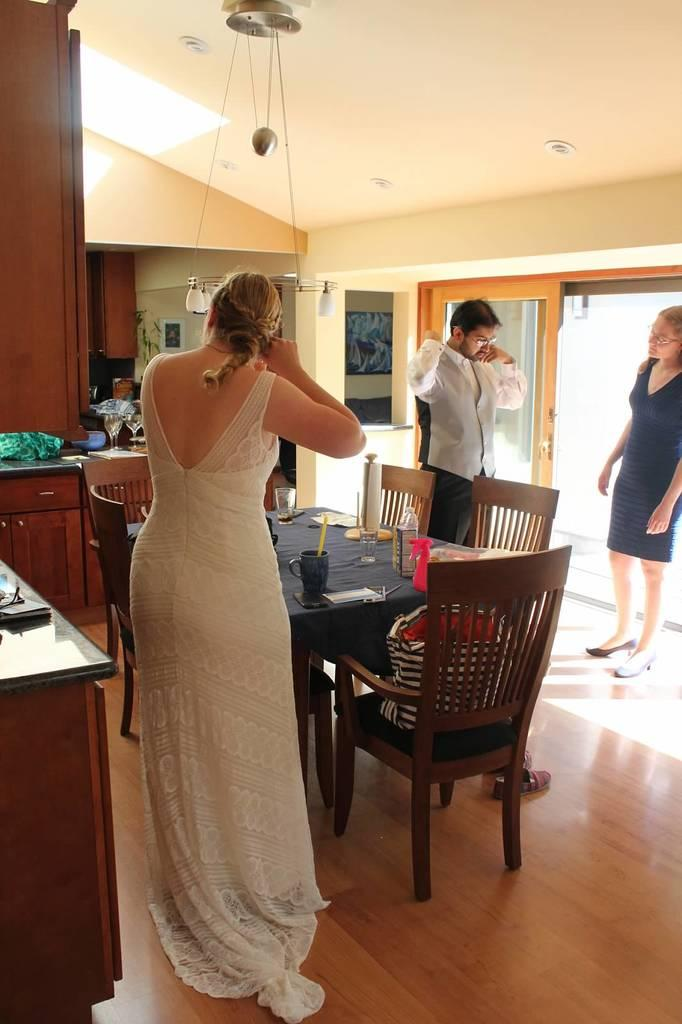What is the gender of the person standing in the image? There is a woman standing in the image. Can you describe the position of the person in the image? The person is standing in the image. What type of rail system is being operated in the image? There is no rail system present in the image; it only features a woman standing. What kind of flight is taking place in the image? There is no flight present in the image; it only features a woman standing. 